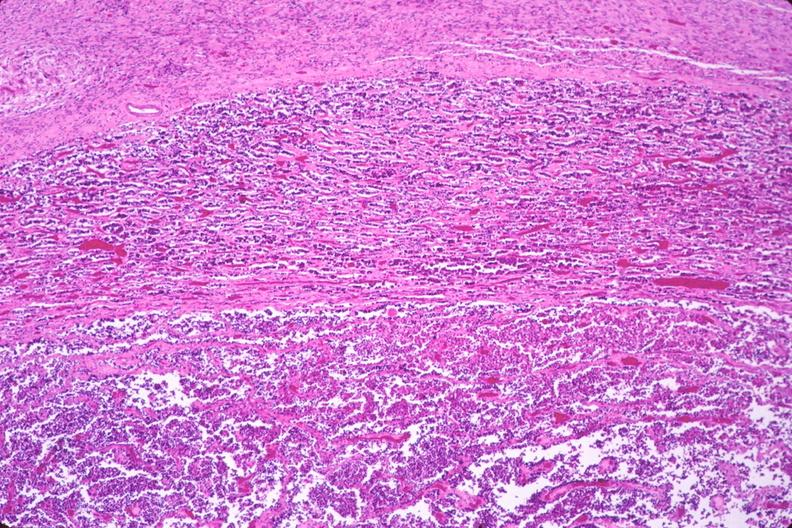what does this image show?
Answer the question using a single word or phrase. Pituitary 